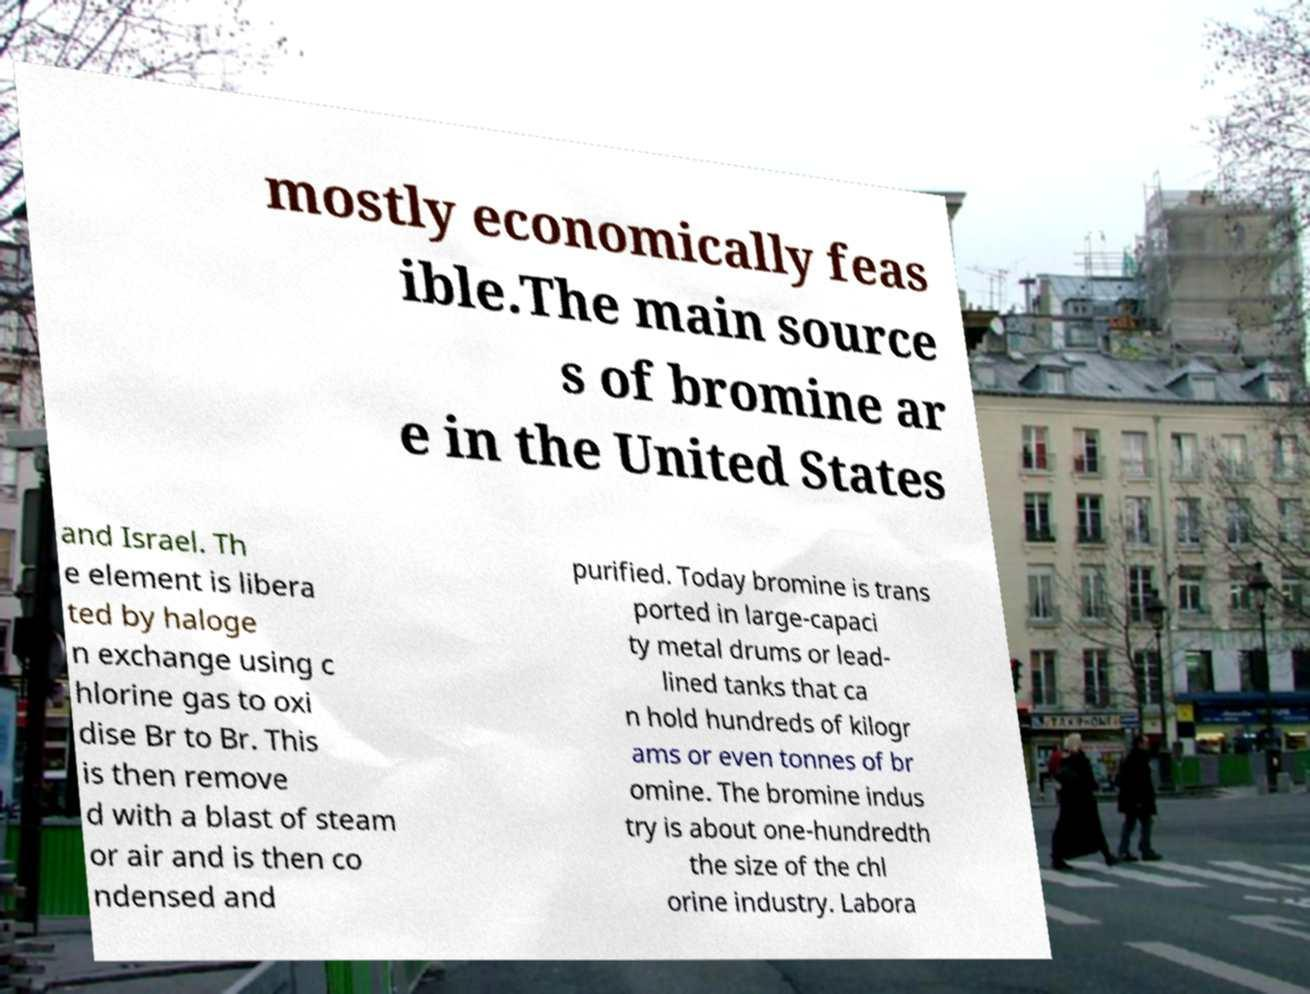Please read and relay the text visible in this image. What does it say? mostly economically feas ible.The main source s of bromine ar e in the United States and Israel. Th e element is libera ted by haloge n exchange using c hlorine gas to oxi dise Br to Br. This is then remove d with a blast of steam or air and is then co ndensed and purified. Today bromine is trans ported in large-capaci ty metal drums or lead- lined tanks that ca n hold hundreds of kilogr ams or even tonnes of br omine. The bromine indus try is about one-hundredth the size of the chl orine industry. Labora 